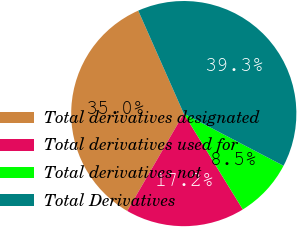Convert chart. <chart><loc_0><loc_0><loc_500><loc_500><pie_chart><fcel>Total derivatives designated<fcel>Total derivatives used for<fcel>Total derivatives not<fcel>Total Derivatives<nl><fcel>35.0%<fcel>17.16%<fcel>8.54%<fcel>39.3%<nl></chart> 